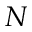Convert formula to latex. <formula><loc_0><loc_0><loc_500><loc_500>N</formula> 